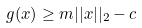<formula> <loc_0><loc_0><loc_500><loc_500>g ( x ) \geq m | | x | | _ { 2 } - c</formula> 